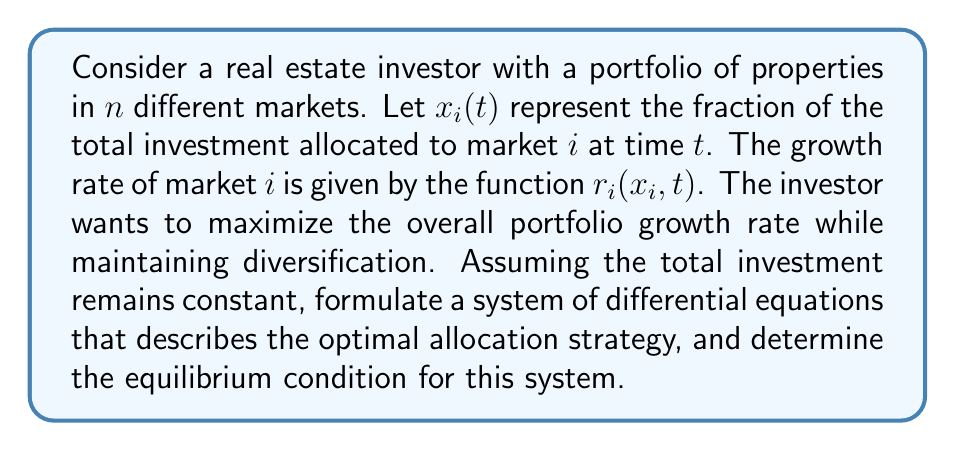Show me your answer to this math problem. 1) First, we need to formulate the differential equations for each market. The rate of change of investment in market $i$ is given by:

   $$\frac{dx_i}{dt} = x_i r_i(x_i, t) - x_i R(t)$$

   where $R(t)$ is the overall portfolio growth rate.

2) The overall portfolio growth rate $R(t)$ is the weighted average of individual market growth rates:

   $$R(t) = \sum_{j=1}^n x_j r_j(x_j, t)$$

3) Since the total investment remains constant, we have the constraint:

   $$\sum_{i=1}^n x_i = 1$$

4) Substituting (2) into (1), we get the system of differential equations:

   $$\frac{dx_i}{dt} = x_i \left(r_i(x_i, t) - \sum_{j=1}^n x_j r_j(x_j, t)\right)$$

5) At equilibrium, $\frac{dx_i}{dt} = 0$ for all $i$. This implies:

   $$x_i \left(r_i(x_i, t) - \sum_{j=1}^n x_j r_j(x_j, t)\right) = 0$$

6) For non-zero allocations ($x_i \neq 0$), this equilibrium condition simplifies to:

   $$r_i(x_i, t) = \sum_{j=1}^n x_j r_j(x_j, t)$$

7) This means that at equilibrium, the growth rate of each market with non-zero allocation should equal the overall portfolio growth rate.
Answer: $$r_i(x_i, t) = \sum_{j=1}^n x_j r_j(x_j, t)$$ for all $i$ where $x_i \neq 0$ 